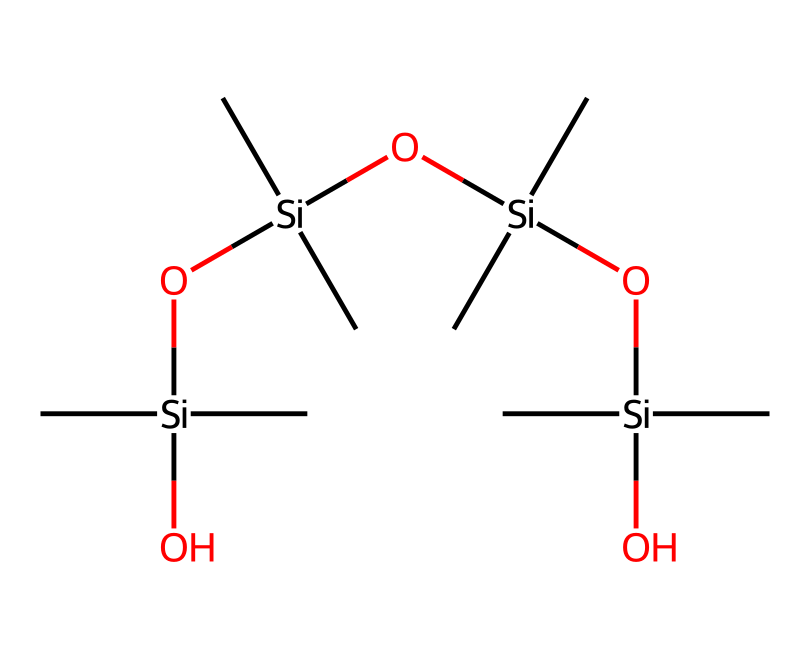how many silicon atoms are in the chemical structure? The given SMILES representation indicates the presence of multiple silicon atoms. By analyzing the structure, we can see there are four instances of the silicon atom represented by each "Si" in the sequence. Thus, the total count of silicon atoms is four.
Answer: four what type of bonds are predominantly present in this chemical structure? In the structure, we see a series of silicon atoms connected to oxygen atoms, forming Si-O bonds. Additionally, there are also C-C and C-O bonds between carbon and oxygen. Thus, the predominant bond type in this chemical structure is Si-O bonds.
Answer: Si-O what functional groups are featured in this silicone compound? To identify the functional groups in this SMILES representation, we look for specific arrangements of atoms. The presence of hydroxyl (-OH) groups linked to silicon atoms indicates that there are silanol functional groups as well as alkyl groups. Therefore, the main functional groups are silanol and alkyl.
Answer: silanol and alkyl what is the overall molecular structure classification of this compound? The presence of silicon, oxygen, and carbon atoms in a polymeric network indicates that this compound belongs to the class of organosilicon compounds. Since it contains long chains of alternating silicon and oxygen atoms with alkyl side chains, it can be classified specifically as a silicone polymer.
Answer: silicone polymer how many oxygen atoms are present in the chemical structure? By examining the SMILES representation more closely, we find that each silicon atom is connected to several oxygen atoms. Each of the four silicon atoms has two oxygen bonds associated with it, leading to a total count of six oxygen atoms in the structure.
Answer: six what property makes silicone sealants suitable for historic building restoration? The molecular structure of silicone sealants, particularly the presence of flexible silicon-oxygen backbones and the absence of water attraction, imparts excellent elasticity and weather resistance properties. These features enable them to accommodate building movement without cracking, making them ideal for restoration.
Answer: elasticity and weather resistance 